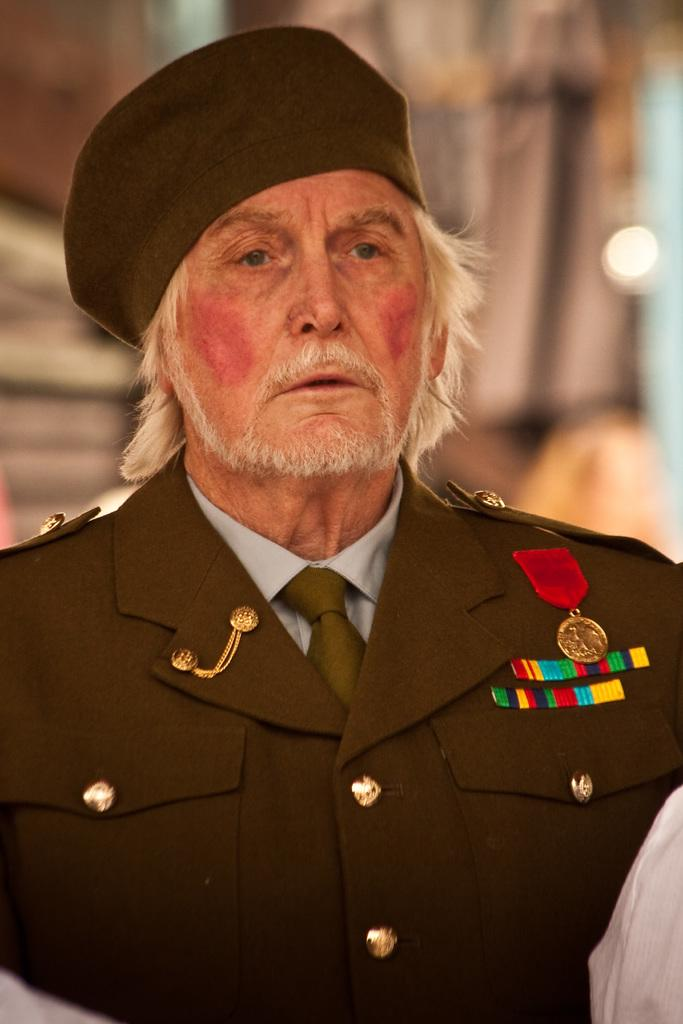Who or what is the main subject in the image? There is a person in the image. What type of clothing is the person wearing? The person is wearing a blazer and a cap. Where is the person located in the image? The person is located in the middle of the image. How much profit did the tin make in the image? There is no tin or profit mentioned in the image; it features a person wearing a blazer and a cap. 